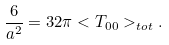Convert formula to latex. <formula><loc_0><loc_0><loc_500><loc_500>\frac { 6 } { a ^ { 2 } } = 3 2 \pi < T _ { 0 0 } > _ { t o t } .</formula> 